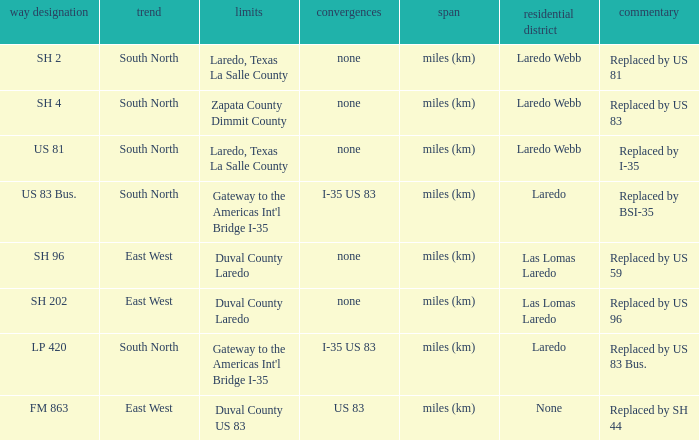Which population areas have "replaced by us 83" listed in their remarks section? Laredo Webb. 